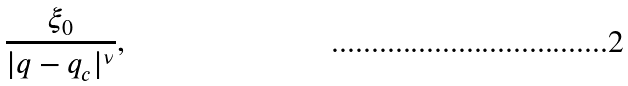<formula> <loc_0><loc_0><loc_500><loc_500>\frac { \xi _ { 0 } } { | q - q _ { c } | ^ { \nu } } ,</formula> 